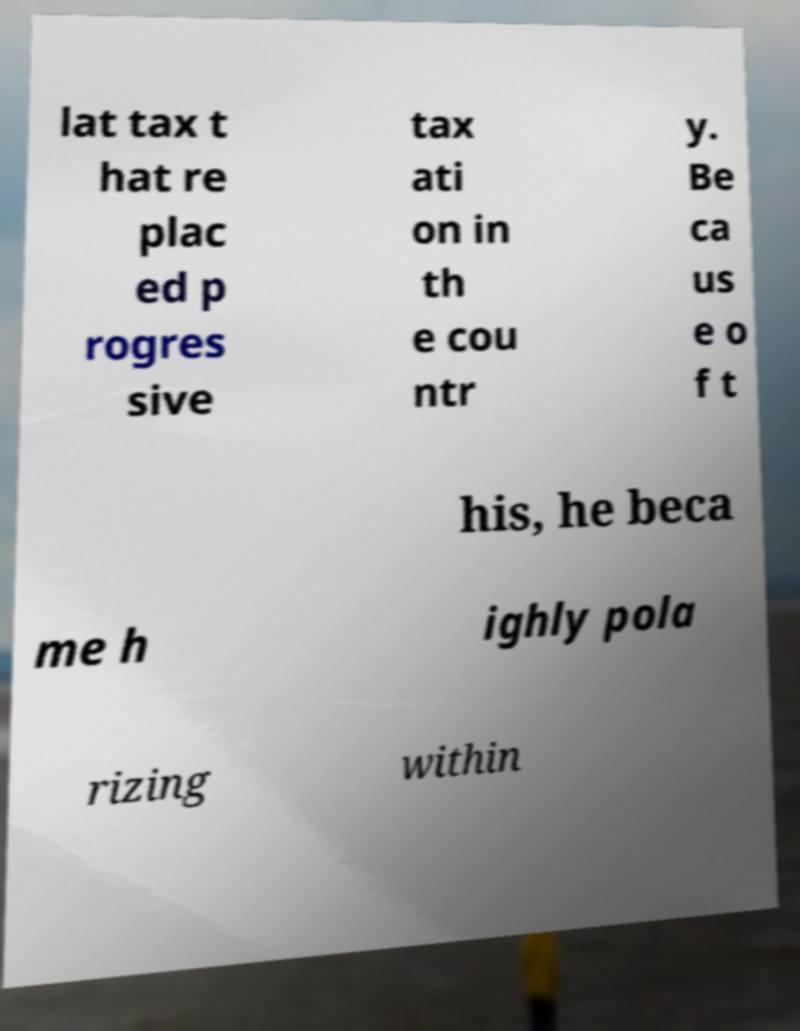There's text embedded in this image that I need extracted. Can you transcribe it verbatim? lat tax t hat re plac ed p rogres sive tax ati on in th e cou ntr y. Be ca us e o f t his, he beca me h ighly pola rizing within 